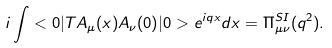<formula> <loc_0><loc_0><loc_500><loc_500>i \int < 0 | T A _ { \mu } ( x ) A _ { \nu } ( 0 ) | 0 > e ^ { i q x } d x = \Pi _ { \mu \nu } ^ { S I } ( q ^ { 2 } ) .</formula> 